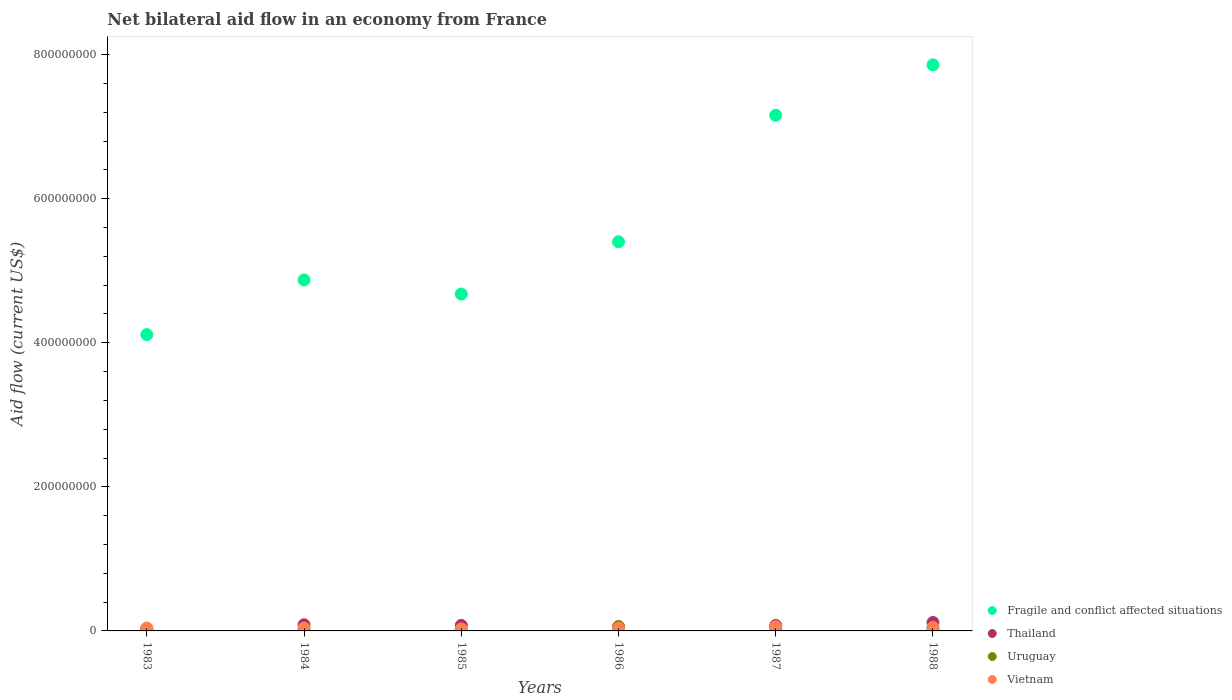Is the number of dotlines equal to the number of legend labels?
Offer a terse response. Yes. What is the net bilateral aid flow in Thailand in 1988?
Offer a terse response. 1.17e+07. Across all years, what is the maximum net bilateral aid flow in Fragile and conflict affected situations?
Offer a very short reply. 7.86e+08. Across all years, what is the minimum net bilateral aid flow in Uruguay?
Provide a succinct answer. 1.18e+06. What is the total net bilateral aid flow in Uruguay in the graph?
Offer a terse response. 1.63e+07. What is the difference between the net bilateral aid flow in Vietnam in 1984 and that in 1985?
Your answer should be very brief. 1.21e+06. What is the difference between the net bilateral aid flow in Uruguay in 1984 and the net bilateral aid flow in Fragile and conflict affected situations in 1983?
Provide a short and direct response. -4.10e+08. What is the average net bilateral aid flow in Vietnam per year?
Provide a succinct answer. 4.24e+06. In the year 1986, what is the difference between the net bilateral aid flow in Uruguay and net bilateral aid flow in Thailand?
Provide a succinct answer. 1.06e+06. In how many years, is the net bilateral aid flow in Fragile and conflict affected situations greater than 400000000 US$?
Your response must be concise. 6. What is the ratio of the net bilateral aid flow in Vietnam in 1983 to that in 1988?
Provide a short and direct response. 0.81. Is the net bilateral aid flow in Fragile and conflict affected situations in 1983 less than that in 1988?
Provide a succinct answer. Yes. What is the difference between the highest and the second highest net bilateral aid flow in Uruguay?
Provide a succinct answer. 2.67e+06. What is the difference between the highest and the lowest net bilateral aid flow in Fragile and conflict affected situations?
Provide a succinct answer. 3.74e+08. Is the sum of the net bilateral aid flow in Vietnam in 1983 and 1987 greater than the maximum net bilateral aid flow in Thailand across all years?
Keep it short and to the point. No. Is the net bilateral aid flow in Fragile and conflict affected situations strictly greater than the net bilateral aid flow in Uruguay over the years?
Offer a terse response. Yes. How many dotlines are there?
Offer a terse response. 4. How many years are there in the graph?
Provide a short and direct response. 6. What is the difference between two consecutive major ticks on the Y-axis?
Keep it short and to the point. 2.00e+08. Does the graph contain any zero values?
Ensure brevity in your answer.  No. Where does the legend appear in the graph?
Your response must be concise. Bottom right. How are the legend labels stacked?
Your answer should be compact. Vertical. What is the title of the graph?
Give a very brief answer. Net bilateral aid flow in an economy from France. Does "Liechtenstein" appear as one of the legend labels in the graph?
Your answer should be compact. No. What is the Aid flow (current US$) of Fragile and conflict affected situations in 1983?
Give a very brief answer. 4.11e+08. What is the Aid flow (current US$) in Thailand in 1983?
Offer a very short reply. 2.84e+06. What is the Aid flow (current US$) of Uruguay in 1983?
Your answer should be compact. 1.50e+06. What is the Aid flow (current US$) in Vietnam in 1983?
Offer a very short reply. 3.98e+06. What is the Aid flow (current US$) in Fragile and conflict affected situations in 1984?
Your answer should be compact. 4.87e+08. What is the Aid flow (current US$) of Thailand in 1984?
Your answer should be very brief. 8.54e+06. What is the Aid flow (current US$) in Uruguay in 1984?
Offer a very short reply. 1.18e+06. What is the Aid flow (current US$) in Vietnam in 1984?
Keep it short and to the point. 3.96e+06. What is the Aid flow (current US$) of Fragile and conflict affected situations in 1985?
Ensure brevity in your answer.  4.68e+08. What is the Aid flow (current US$) of Thailand in 1985?
Give a very brief answer. 7.63e+06. What is the Aid flow (current US$) in Uruguay in 1985?
Give a very brief answer. 1.66e+06. What is the Aid flow (current US$) of Vietnam in 1985?
Make the answer very short. 2.75e+06. What is the Aid flow (current US$) of Fragile and conflict affected situations in 1986?
Give a very brief answer. 5.40e+08. What is the Aid flow (current US$) of Thailand in 1986?
Your answer should be compact. 5.08e+06. What is the Aid flow (current US$) in Uruguay in 1986?
Make the answer very short. 6.14e+06. What is the Aid flow (current US$) in Vietnam in 1986?
Your answer should be compact. 3.90e+06. What is the Aid flow (current US$) of Fragile and conflict affected situations in 1987?
Your response must be concise. 7.16e+08. What is the Aid flow (current US$) in Thailand in 1987?
Your answer should be very brief. 7.65e+06. What is the Aid flow (current US$) of Uruguay in 1987?
Your answer should be very brief. 2.33e+06. What is the Aid flow (current US$) of Vietnam in 1987?
Offer a terse response. 5.94e+06. What is the Aid flow (current US$) in Fragile and conflict affected situations in 1988?
Provide a succinct answer. 7.86e+08. What is the Aid flow (current US$) in Thailand in 1988?
Make the answer very short. 1.17e+07. What is the Aid flow (current US$) of Uruguay in 1988?
Offer a very short reply. 3.47e+06. What is the Aid flow (current US$) in Vietnam in 1988?
Provide a succinct answer. 4.90e+06. Across all years, what is the maximum Aid flow (current US$) of Fragile and conflict affected situations?
Offer a terse response. 7.86e+08. Across all years, what is the maximum Aid flow (current US$) in Thailand?
Keep it short and to the point. 1.17e+07. Across all years, what is the maximum Aid flow (current US$) in Uruguay?
Your response must be concise. 6.14e+06. Across all years, what is the maximum Aid flow (current US$) in Vietnam?
Make the answer very short. 5.94e+06. Across all years, what is the minimum Aid flow (current US$) of Fragile and conflict affected situations?
Your answer should be very brief. 4.11e+08. Across all years, what is the minimum Aid flow (current US$) of Thailand?
Your answer should be compact. 2.84e+06. Across all years, what is the minimum Aid flow (current US$) in Uruguay?
Your answer should be compact. 1.18e+06. Across all years, what is the minimum Aid flow (current US$) in Vietnam?
Your answer should be compact. 2.75e+06. What is the total Aid flow (current US$) in Fragile and conflict affected situations in the graph?
Make the answer very short. 3.41e+09. What is the total Aid flow (current US$) of Thailand in the graph?
Your answer should be very brief. 4.34e+07. What is the total Aid flow (current US$) of Uruguay in the graph?
Your answer should be compact. 1.63e+07. What is the total Aid flow (current US$) in Vietnam in the graph?
Keep it short and to the point. 2.54e+07. What is the difference between the Aid flow (current US$) in Fragile and conflict affected situations in 1983 and that in 1984?
Give a very brief answer. -7.59e+07. What is the difference between the Aid flow (current US$) of Thailand in 1983 and that in 1984?
Ensure brevity in your answer.  -5.70e+06. What is the difference between the Aid flow (current US$) in Uruguay in 1983 and that in 1984?
Offer a very short reply. 3.20e+05. What is the difference between the Aid flow (current US$) in Fragile and conflict affected situations in 1983 and that in 1985?
Make the answer very short. -5.63e+07. What is the difference between the Aid flow (current US$) in Thailand in 1983 and that in 1985?
Offer a terse response. -4.79e+06. What is the difference between the Aid flow (current US$) in Vietnam in 1983 and that in 1985?
Give a very brief answer. 1.23e+06. What is the difference between the Aid flow (current US$) of Fragile and conflict affected situations in 1983 and that in 1986?
Keep it short and to the point. -1.29e+08. What is the difference between the Aid flow (current US$) of Thailand in 1983 and that in 1986?
Ensure brevity in your answer.  -2.24e+06. What is the difference between the Aid flow (current US$) in Uruguay in 1983 and that in 1986?
Provide a short and direct response. -4.64e+06. What is the difference between the Aid flow (current US$) of Vietnam in 1983 and that in 1986?
Give a very brief answer. 8.00e+04. What is the difference between the Aid flow (current US$) of Fragile and conflict affected situations in 1983 and that in 1987?
Your answer should be compact. -3.04e+08. What is the difference between the Aid flow (current US$) in Thailand in 1983 and that in 1987?
Provide a succinct answer. -4.81e+06. What is the difference between the Aid flow (current US$) of Uruguay in 1983 and that in 1987?
Provide a short and direct response. -8.30e+05. What is the difference between the Aid flow (current US$) in Vietnam in 1983 and that in 1987?
Offer a terse response. -1.96e+06. What is the difference between the Aid flow (current US$) in Fragile and conflict affected situations in 1983 and that in 1988?
Provide a short and direct response. -3.74e+08. What is the difference between the Aid flow (current US$) of Thailand in 1983 and that in 1988?
Make the answer very short. -8.84e+06. What is the difference between the Aid flow (current US$) of Uruguay in 1983 and that in 1988?
Make the answer very short. -1.97e+06. What is the difference between the Aid flow (current US$) in Vietnam in 1983 and that in 1988?
Provide a short and direct response. -9.20e+05. What is the difference between the Aid flow (current US$) in Fragile and conflict affected situations in 1984 and that in 1985?
Keep it short and to the point. 1.96e+07. What is the difference between the Aid flow (current US$) in Thailand in 1984 and that in 1985?
Provide a succinct answer. 9.10e+05. What is the difference between the Aid flow (current US$) in Uruguay in 1984 and that in 1985?
Give a very brief answer. -4.80e+05. What is the difference between the Aid flow (current US$) of Vietnam in 1984 and that in 1985?
Provide a short and direct response. 1.21e+06. What is the difference between the Aid flow (current US$) of Fragile and conflict affected situations in 1984 and that in 1986?
Your answer should be compact. -5.29e+07. What is the difference between the Aid flow (current US$) of Thailand in 1984 and that in 1986?
Your answer should be very brief. 3.46e+06. What is the difference between the Aid flow (current US$) of Uruguay in 1984 and that in 1986?
Make the answer very short. -4.96e+06. What is the difference between the Aid flow (current US$) of Vietnam in 1984 and that in 1986?
Keep it short and to the point. 6.00e+04. What is the difference between the Aid flow (current US$) of Fragile and conflict affected situations in 1984 and that in 1987?
Your answer should be compact. -2.29e+08. What is the difference between the Aid flow (current US$) in Thailand in 1984 and that in 1987?
Your response must be concise. 8.90e+05. What is the difference between the Aid flow (current US$) in Uruguay in 1984 and that in 1987?
Provide a succinct answer. -1.15e+06. What is the difference between the Aid flow (current US$) in Vietnam in 1984 and that in 1987?
Provide a succinct answer. -1.98e+06. What is the difference between the Aid flow (current US$) in Fragile and conflict affected situations in 1984 and that in 1988?
Offer a terse response. -2.99e+08. What is the difference between the Aid flow (current US$) in Thailand in 1984 and that in 1988?
Keep it short and to the point. -3.14e+06. What is the difference between the Aid flow (current US$) of Uruguay in 1984 and that in 1988?
Your answer should be very brief. -2.29e+06. What is the difference between the Aid flow (current US$) of Vietnam in 1984 and that in 1988?
Your answer should be compact. -9.40e+05. What is the difference between the Aid flow (current US$) in Fragile and conflict affected situations in 1985 and that in 1986?
Make the answer very short. -7.26e+07. What is the difference between the Aid flow (current US$) of Thailand in 1985 and that in 1986?
Provide a succinct answer. 2.55e+06. What is the difference between the Aid flow (current US$) of Uruguay in 1985 and that in 1986?
Provide a succinct answer. -4.48e+06. What is the difference between the Aid flow (current US$) of Vietnam in 1985 and that in 1986?
Your answer should be compact. -1.15e+06. What is the difference between the Aid flow (current US$) in Fragile and conflict affected situations in 1985 and that in 1987?
Offer a terse response. -2.48e+08. What is the difference between the Aid flow (current US$) in Uruguay in 1985 and that in 1987?
Ensure brevity in your answer.  -6.70e+05. What is the difference between the Aid flow (current US$) in Vietnam in 1985 and that in 1987?
Offer a terse response. -3.19e+06. What is the difference between the Aid flow (current US$) in Fragile and conflict affected situations in 1985 and that in 1988?
Offer a terse response. -3.18e+08. What is the difference between the Aid flow (current US$) of Thailand in 1985 and that in 1988?
Provide a short and direct response. -4.05e+06. What is the difference between the Aid flow (current US$) of Uruguay in 1985 and that in 1988?
Keep it short and to the point. -1.81e+06. What is the difference between the Aid flow (current US$) in Vietnam in 1985 and that in 1988?
Provide a succinct answer. -2.15e+06. What is the difference between the Aid flow (current US$) in Fragile and conflict affected situations in 1986 and that in 1987?
Your answer should be very brief. -1.76e+08. What is the difference between the Aid flow (current US$) of Thailand in 1986 and that in 1987?
Ensure brevity in your answer.  -2.57e+06. What is the difference between the Aid flow (current US$) in Uruguay in 1986 and that in 1987?
Your response must be concise. 3.81e+06. What is the difference between the Aid flow (current US$) in Vietnam in 1986 and that in 1987?
Provide a succinct answer. -2.04e+06. What is the difference between the Aid flow (current US$) in Fragile and conflict affected situations in 1986 and that in 1988?
Your response must be concise. -2.46e+08. What is the difference between the Aid flow (current US$) of Thailand in 1986 and that in 1988?
Your response must be concise. -6.60e+06. What is the difference between the Aid flow (current US$) of Uruguay in 1986 and that in 1988?
Your response must be concise. 2.67e+06. What is the difference between the Aid flow (current US$) of Vietnam in 1986 and that in 1988?
Keep it short and to the point. -1.00e+06. What is the difference between the Aid flow (current US$) in Fragile and conflict affected situations in 1987 and that in 1988?
Your answer should be very brief. -7.00e+07. What is the difference between the Aid flow (current US$) of Thailand in 1987 and that in 1988?
Your response must be concise. -4.03e+06. What is the difference between the Aid flow (current US$) of Uruguay in 1987 and that in 1988?
Make the answer very short. -1.14e+06. What is the difference between the Aid flow (current US$) in Vietnam in 1987 and that in 1988?
Keep it short and to the point. 1.04e+06. What is the difference between the Aid flow (current US$) of Fragile and conflict affected situations in 1983 and the Aid flow (current US$) of Thailand in 1984?
Your answer should be very brief. 4.03e+08. What is the difference between the Aid flow (current US$) in Fragile and conflict affected situations in 1983 and the Aid flow (current US$) in Uruguay in 1984?
Your answer should be very brief. 4.10e+08. What is the difference between the Aid flow (current US$) in Fragile and conflict affected situations in 1983 and the Aid flow (current US$) in Vietnam in 1984?
Your response must be concise. 4.07e+08. What is the difference between the Aid flow (current US$) in Thailand in 1983 and the Aid flow (current US$) in Uruguay in 1984?
Keep it short and to the point. 1.66e+06. What is the difference between the Aid flow (current US$) in Thailand in 1983 and the Aid flow (current US$) in Vietnam in 1984?
Your response must be concise. -1.12e+06. What is the difference between the Aid flow (current US$) in Uruguay in 1983 and the Aid flow (current US$) in Vietnam in 1984?
Your answer should be compact. -2.46e+06. What is the difference between the Aid flow (current US$) of Fragile and conflict affected situations in 1983 and the Aid flow (current US$) of Thailand in 1985?
Ensure brevity in your answer.  4.04e+08. What is the difference between the Aid flow (current US$) in Fragile and conflict affected situations in 1983 and the Aid flow (current US$) in Uruguay in 1985?
Keep it short and to the point. 4.10e+08. What is the difference between the Aid flow (current US$) of Fragile and conflict affected situations in 1983 and the Aid flow (current US$) of Vietnam in 1985?
Offer a very short reply. 4.09e+08. What is the difference between the Aid flow (current US$) of Thailand in 1983 and the Aid flow (current US$) of Uruguay in 1985?
Ensure brevity in your answer.  1.18e+06. What is the difference between the Aid flow (current US$) of Thailand in 1983 and the Aid flow (current US$) of Vietnam in 1985?
Give a very brief answer. 9.00e+04. What is the difference between the Aid flow (current US$) of Uruguay in 1983 and the Aid flow (current US$) of Vietnam in 1985?
Provide a short and direct response. -1.25e+06. What is the difference between the Aid flow (current US$) of Fragile and conflict affected situations in 1983 and the Aid flow (current US$) of Thailand in 1986?
Your answer should be compact. 4.06e+08. What is the difference between the Aid flow (current US$) in Fragile and conflict affected situations in 1983 and the Aid flow (current US$) in Uruguay in 1986?
Offer a terse response. 4.05e+08. What is the difference between the Aid flow (current US$) of Fragile and conflict affected situations in 1983 and the Aid flow (current US$) of Vietnam in 1986?
Offer a terse response. 4.07e+08. What is the difference between the Aid flow (current US$) in Thailand in 1983 and the Aid flow (current US$) in Uruguay in 1986?
Provide a succinct answer. -3.30e+06. What is the difference between the Aid flow (current US$) in Thailand in 1983 and the Aid flow (current US$) in Vietnam in 1986?
Offer a very short reply. -1.06e+06. What is the difference between the Aid flow (current US$) of Uruguay in 1983 and the Aid flow (current US$) of Vietnam in 1986?
Make the answer very short. -2.40e+06. What is the difference between the Aid flow (current US$) of Fragile and conflict affected situations in 1983 and the Aid flow (current US$) of Thailand in 1987?
Keep it short and to the point. 4.04e+08. What is the difference between the Aid flow (current US$) in Fragile and conflict affected situations in 1983 and the Aid flow (current US$) in Uruguay in 1987?
Offer a very short reply. 4.09e+08. What is the difference between the Aid flow (current US$) of Fragile and conflict affected situations in 1983 and the Aid flow (current US$) of Vietnam in 1987?
Offer a very short reply. 4.05e+08. What is the difference between the Aid flow (current US$) in Thailand in 1983 and the Aid flow (current US$) in Uruguay in 1987?
Provide a succinct answer. 5.10e+05. What is the difference between the Aid flow (current US$) in Thailand in 1983 and the Aid flow (current US$) in Vietnam in 1987?
Offer a terse response. -3.10e+06. What is the difference between the Aid flow (current US$) in Uruguay in 1983 and the Aid flow (current US$) in Vietnam in 1987?
Your answer should be compact. -4.44e+06. What is the difference between the Aid flow (current US$) in Fragile and conflict affected situations in 1983 and the Aid flow (current US$) in Thailand in 1988?
Give a very brief answer. 4.00e+08. What is the difference between the Aid flow (current US$) of Fragile and conflict affected situations in 1983 and the Aid flow (current US$) of Uruguay in 1988?
Your answer should be compact. 4.08e+08. What is the difference between the Aid flow (current US$) in Fragile and conflict affected situations in 1983 and the Aid flow (current US$) in Vietnam in 1988?
Give a very brief answer. 4.06e+08. What is the difference between the Aid flow (current US$) of Thailand in 1983 and the Aid flow (current US$) of Uruguay in 1988?
Ensure brevity in your answer.  -6.30e+05. What is the difference between the Aid flow (current US$) in Thailand in 1983 and the Aid flow (current US$) in Vietnam in 1988?
Make the answer very short. -2.06e+06. What is the difference between the Aid flow (current US$) in Uruguay in 1983 and the Aid flow (current US$) in Vietnam in 1988?
Your answer should be compact. -3.40e+06. What is the difference between the Aid flow (current US$) of Fragile and conflict affected situations in 1984 and the Aid flow (current US$) of Thailand in 1985?
Your answer should be very brief. 4.80e+08. What is the difference between the Aid flow (current US$) of Fragile and conflict affected situations in 1984 and the Aid flow (current US$) of Uruguay in 1985?
Keep it short and to the point. 4.86e+08. What is the difference between the Aid flow (current US$) in Fragile and conflict affected situations in 1984 and the Aid flow (current US$) in Vietnam in 1985?
Give a very brief answer. 4.84e+08. What is the difference between the Aid flow (current US$) in Thailand in 1984 and the Aid flow (current US$) in Uruguay in 1985?
Your response must be concise. 6.88e+06. What is the difference between the Aid flow (current US$) in Thailand in 1984 and the Aid flow (current US$) in Vietnam in 1985?
Ensure brevity in your answer.  5.79e+06. What is the difference between the Aid flow (current US$) of Uruguay in 1984 and the Aid flow (current US$) of Vietnam in 1985?
Give a very brief answer. -1.57e+06. What is the difference between the Aid flow (current US$) in Fragile and conflict affected situations in 1984 and the Aid flow (current US$) in Thailand in 1986?
Your answer should be compact. 4.82e+08. What is the difference between the Aid flow (current US$) of Fragile and conflict affected situations in 1984 and the Aid flow (current US$) of Uruguay in 1986?
Your response must be concise. 4.81e+08. What is the difference between the Aid flow (current US$) of Fragile and conflict affected situations in 1984 and the Aid flow (current US$) of Vietnam in 1986?
Your answer should be very brief. 4.83e+08. What is the difference between the Aid flow (current US$) in Thailand in 1984 and the Aid flow (current US$) in Uruguay in 1986?
Provide a short and direct response. 2.40e+06. What is the difference between the Aid flow (current US$) of Thailand in 1984 and the Aid flow (current US$) of Vietnam in 1986?
Your response must be concise. 4.64e+06. What is the difference between the Aid flow (current US$) in Uruguay in 1984 and the Aid flow (current US$) in Vietnam in 1986?
Make the answer very short. -2.72e+06. What is the difference between the Aid flow (current US$) of Fragile and conflict affected situations in 1984 and the Aid flow (current US$) of Thailand in 1987?
Your response must be concise. 4.80e+08. What is the difference between the Aid flow (current US$) of Fragile and conflict affected situations in 1984 and the Aid flow (current US$) of Uruguay in 1987?
Provide a short and direct response. 4.85e+08. What is the difference between the Aid flow (current US$) of Fragile and conflict affected situations in 1984 and the Aid flow (current US$) of Vietnam in 1987?
Your answer should be very brief. 4.81e+08. What is the difference between the Aid flow (current US$) of Thailand in 1984 and the Aid flow (current US$) of Uruguay in 1987?
Provide a succinct answer. 6.21e+06. What is the difference between the Aid flow (current US$) in Thailand in 1984 and the Aid flow (current US$) in Vietnam in 1987?
Provide a short and direct response. 2.60e+06. What is the difference between the Aid flow (current US$) of Uruguay in 1984 and the Aid flow (current US$) of Vietnam in 1987?
Offer a very short reply. -4.76e+06. What is the difference between the Aid flow (current US$) of Fragile and conflict affected situations in 1984 and the Aid flow (current US$) of Thailand in 1988?
Give a very brief answer. 4.76e+08. What is the difference between the Aid flow (current US$) in Fragile and conflict affected situations in 1984 and the Aid flow (current US$) in Uruguay in 1988?
Provide a short and direct response. 4.84e+08. What is the difference between the Aid flow (current US$) in Fragile and conflict affected situations in 1984 and the Aid flow (current US$) in Vietnam in 1988?
Offer a very short reply. 4.82e+08. What is the difference between the Aid flow (current US$) of Thailand in 1984 and the Aid flow (current US$) of Uruguay in 1988?
Your answer should be very brief. 5.07e+06. What is the difference between the Aid flow (current US$) of Thailand in 1984 and the Aid flow (current US$) of Vietnam in 1988?
Offer a very short reply. 3.64e+06. What is the difference between the Aid flow (current US$) in Uruguay in 1984 and the Aid flow (current US$) in Vietnam in 1988?
Provide a short and direct response. -3.72e+06. What is the difference between the Aid flow (current US$) of Fragile and conflict affected situations in 1985 and the Aid flow (current US$) of Thailand in 1986?
Make the answer very short. 4.63e+08. What is the difference between the Aid flow (current US$) in Fragile and conflict affected situations in 1985 and the Aid flow (current US$) in Uruguay in 1986?
Offer a terse response. 4.61e+08. What is the difference between the Aid flow (current US$) of Fragile and conflict affected situations in 1985 and the Aid flow (current US$) of Vietnam in 1986?
Make the answer very short. 4.64e+08. What is the difference between the Aid flow (current US$) in Thailand in 1985 and the Aid flow (current US$) in Uruguay in 1986?
Make the answer very short. 1.49e+06. What is the difference between the Aid flow (current US$) of Thailand in 1985 and the Aid flow (current US$) of Vietnam in 1986?
Provide a short and direct response. 3.73e+06. What is the difference between the Aid flow (current US$) in Uruguay in 1985 and the Aid flow (current US$) in Vietnam in 1986?
Give a very brief answer. -2.24e+06. What is the difference between the Aid flow (current US$) in Fragile and conflict affected situations in 1985 and the Aid flow (current US$) in Thailand in 1987?
Make the answer very short. 4.60e+08. What is the difference between the Aid flow (current US$) of Fragile and conflict affected situations in 1985 and the Aid flow (current US$) of Uruguay in 1987?
Provide a succinct answer. 4.65e+08. What is the difference between the Aid flow (current US$) of Fragile and conflict affected situations in 1985 and the Aid flow (current US$) of Vietnam in 1987?
Your answer should be very brief. 4.62e+08. What is the difference between the Aid flow (current US$) in Thailand in 1985 and the Aid flow (current US$) in Uruguay in 1987?
Give a very brief answer. 5.30e+06. What is the difference between the Aid flow (current US$) of Thailand in 1985 and the Aid flow (current US$) of Vietnam in 1987?
Make the answer very short. 1.69e+06. What is the difference between the Aid flow (current US$) in Uruguay in 1985 and the Aid flow (current US$) in Vietnam in 1987?
Keep it short and to the point. -4.28e+06. What is the difference between the Aid flow (current US$) of Fragile and conflict affected situations in 1985 and the Aid flow (current US$) of Thailand in 1988?
Give a very brief answer. 4.56e+08. What is the difference between the Aid flow (current US$) in Fragile and conflict affected situations in 1985 and the Aid flow (current US$) in Uruguay in 1988?
Provide a succinct answer. 4.64e+08. What is the difference between the Aid flow (current US$) of Fragile and conflict affected situations in 1985 and the Aid flow (current US$) of Vietnam in 1988?
Your answer should be very brief. 4.63e+08. What is the difference between the Aid flow (current US$) in Thailand in 1985 and the Aid flow (current US$) in Uruguay in 1988?
Your response must be concise. 4.16e+06. What is the difference between the Aid flow (current US$) in Thailand in 1985 and the Aid flow (current US$) in Vietnam in 1988?
Ensure brevity in your answer.  2.73e+06. What is the difference between the Aid flow (current US$) of Uruguay in 1985 and the Aid flow (current US$) of Vietnam in 1988?
Offer a terse response. -3.24e+06. What is the difference between the Aid flow (current US$) of Fragile and conflict affected situations in 1986 and the Aid flow (current US$) of Thailand in 1987?
Ensure brevity in your answer.  5.33e+08. What is the difference between the Aid flow (current US$) in Fragile and conflict affected situations in 1986 and the Aid flow (current US$) in Uruguay in 1987?
Your answer should be very brief. 5.38e+08. What is the difference between the Aid flow (current US$) of Fragile and conflict affected situations in 1986 and the Aid flow (current US$) of Vietnam in 1987?
Make the answer very short. 5.34e+08. What is the difference between the Aid flow (current US$) in Thailand in 1986 and the Aid flow (current US$) in Uruguay in 1987?
Provide a succinct answer. 2.75e+06. What is the difference between the Aid flow (current US$) in Thailand in 1986 and the Aid flow (current US$) in Vietnam in 1987?
Provide a succinct answer. -8.60e+05. What is the difference between the Aid flow (current US$) in Uruguay in 1986 and the Aid flow (current US$) in Vietnam in 1987?
Offer a very short reply. 2.00e+05. What is the difference between the Aid flow (current US$) in Fragile and conflict affected situations in 1986 and the Aid flow (current US$) in Thailand in 1988?
Offer a terse response. 5.28e+08. What is the difference between the Aid flow (current US$) of Fragile and conflict affected situations in 1986 and the Aid flow (current US$) of Uruguay in 1988?
Give a very brief answer. 5.37e+08. What is the difference between the Aid flow (current US$) of Fragile and conflict affected situations in 1986 and the Aid flow (current US$) of Vietnam in 1988?
Provide a succinct answer. 5.35e+08. What is the difference between the Aid flow (current US$) in Thailand in 1986 and the Aid flow (current US$) in Uruguay in 1988?
Offer a terse response. 1.61e+06. What is the difference between the Aid flow (current US$) in Thailand in 1986 and the Aid flow (current US$) in Vietnam in 1988?
Make the answer very short. 1.80e+05. What is the difference between the Aid flow (current US$) of Uruguay in 1986 and the Aid flow (current US$) of Vietnam in 1988?
Your answer should be very brief. 1.24e+06. What is the difference between the Aid flow (current US$) in Fragile and conflict affected situations in 1987 and the Aid flow (current US$) in Thailand in 1988?
Offer a terse response. 7.04e+08. What is the difference between the Aid flow (current US$) of Fragile and conflict affected situations in 1987 and the Aid flow (current US$) of Uruguay in 1988?
Ensure brevity in your answer.  7.12e+08. What is the difference between the Aid flow (current US$) in Fragile and conflict affected situations in 1987 and the Aid flow (current US$) in Vietnam in 1988?
Keep it short and to the point. 7.11e+08. What is the difference between the Aid flow (current US$) of Thailand in 1987 and the Aid flow (current US$) of Uruguay in 1988?
Your response must be concise. 4.18e+06. What is the difference between the Aid flow (current US$) in Thailand in 1987 and the Aid flow (current US$) in Vietnam in 1988?
Make the answer very short. 2.75e+06. What is the difference between the Aid flow (current US$) in Uruguay in 1987 and the Aid flow (current US$) in Vietnam in 1988?
Provide a succinct answer. -2.57e+06. What is the average Aid flow (current US$) of Fragile and conflict affected situations per year?
Make the answer very short. 5.68e+08. What is the average Aid flow (current US$) in Thailand per year?
Offer a very short reply. 7.24e+06. What is the average Aid flow (current US$) of Uruguay per year?
Offer a very short reply. 2.71e+06. What is the average Aid flow (current US$) of Vietnam per year?
Give a very brief answer. 4.24e+06. In the year 1983, what is the difference between the Aid flow (current US$) in Fragile and conflict affected situations and Aid flow (current US$) in Thailand?
Ensure brevity in your answer.  4.08e+08. In the year 1983, what is the difference between the Aid flow (current US$) of Fragile and conflict affected situations and Aid flow (current US$) of Uruguay?
Provide a short and direct response. 4.10e+08. In the year 1983, what is the difference between the Aid flow (current US$) in Fragile and conflict affected situations and Aid flow (current US$) in Vietnam?
Make the answer very short. 4.07e+08. In the year 1983, what is the difference between the Aid flow (current US$) in Thailand and Aid flow (current US$) in Uruguay?
Make the answer very short. 1.34e+06. In the year 1983, what is the difference between the Aid flow (current US$) of Thailand and Aid flow (current US$) of Vietnam?
Offer a terse response. -1.14e+06. In the year 1983, what is the difference between the Aid flow (current US$) of Uruguay and Aid flow (current US$) of Vietnam?
Make the answer very short. -2.48e+06. In the year 1984, what is the difference between the Aid flow (current US$) in Fragile and conflict affected situations and Aid flow (current US$) in Thailand?
Make the answer very short. 4.79e+08. In the year 1984, what is the difference between the Aid flow (current US$) of Fragile and conflict affected situations and Aid flow (current US$) of Uruguay?
Make the answer very short. 4.86e+08. In the year 1984, what is the difference between the Aid flow (current US$) in Fragile and conflict affected situations and Aid flow (current US$) in Vietnam?
Offer a very short reply. 4.83e+08. In the year 1984, what is the difference between the Aid flow (current US$) in Thailand and Aid flow (current US$) in Uruguay?
Ensure brevity in your answer.  7.36e+06. In the year 1984, what is the difference between the Aid flow (current US$) in Thailand and Aid flow (current US$) in Vietnam?
Give a very brief answer. 4.58e+06. In the year 1984, what is the difference between the Aid flow (current US$) in Uruguay and Aid flow (current US$) in Vietnam?
Provide a succinct answer. -2.78e+06. In the year 1985, what is the difference between the Aid flow (current US$) of Fragile and conflict affected situations and Aid flow (current US$) of Thailand?
Your answer should be compact. 4.60e+08. In the year 1985, what is the difference between the Aid flow (current US$) of Fragile and conflict affected situations and Aid flow (current US$) of Uruguay?
Make the answer very short. 4.66e+08. In the year 1985, what is the difference between the Aid flow (current US$) in Fragile and conflict affected situations and Aid flow (current US$) in Vietnam?
Your answer should be compact. 4.65e+08. In the year 1985, what is the difference between the Aid flow (current US$) of Thailand and Aid flow (current US$) of Uruguay?
Make the answer very short. 5.97e+06. In the year 1985, what is the difference between the Aid flow (current US$) of Thailand and Aid flow (current US$) of Vietnam?
Make the answer very short. 4.88e+06. In the year 1985, what is the difference between the Aid flow (current US$) in Uruguay and Aid flow (current US$) in Vietnam?
Give a very brief answer. -1.09e+06. In the year 1986, what is the difference between the Aid flow (current US$) in Fragile and conflict affected situations and Aid flow (current US$) in Thailand?
Provide a succinct answer. 5.35e+08. In the year 1986, what is the difference between the Aid flow (current US$) in Fragile and conflict affected situations and Aid flow (current US$) in Uruguay?
Your answer should be compact. 5.34e+08. In the year 1986, what is the difference between the Aid flow (current US$) of Fragile and conflict affected situations and Aid flow (current US$) of Vietnam?
Keep it short and to the point. 5.36e+08. In the year 1986, what is the difference between the Aid flow (current US$) of Thailand and Aid flow (current US$) of Uruguay?
Keep it short and to the point. -1.06e+06. In the year 1986, what is the difference between the Aid flow (current US$) of Thailand and Aid flow (current US$) of Vietnam?
Give a very brief answer. 1.18e+06. In the year 1986, what is the difference between the Aid flow (current US$) in Uruguay and Aid flow (current US$) in Vietnam?
Give a very brief answer. 2.24e+06. In the year 1987, what is the difference between the Aid flow (current US$) of Fragile and conflict affected situations and Aid flow (current US$) of Thailand?
Your response must be concise. 7.08e+08. In the year 1987, what is the difference between the Aid flow (current US$) of Fragile and conflict affected situations and Aid flow (current US$) of Uruguay?
Provide a short and direct response. 7.13e+08. In the year 1987, what is the difference between the Aid flow (current US$) of Fragile and conflict affected situations and Aid flow (current US$) of Vietnam?
Offer a very short reply. 7.10e+08. In the year 1987, what is the difference between the Aid flow (current US$) in Thailand and Aid flow (current US$) in Uruguay?
Your answer should be very brief. 5.32e+06. In the year 1987, what is the difference between the Aid flow (current US$) in Thailand and Aid flow (current US$) in Vietnam?
Your answer should be very brief. 1.71e+06. In the year 1987, what is the difference between the Aid flow (current US$) of Uruguay and Aid flow (current US$) of Vietnam?
Your answer should be compact. -3.61e+06. In the year 1988, what is the difference between the Aid flow (current US$) of Fragile and conflict affected situations and Aid flow (current US$) of Thailand?
Offer a very short reply. 7.74e+08. In the year 1988, what is the difference between the Aid flow (current US$) of Fragile and conflict affected situations and Aid flow (current US$) of Uruguay?
Give a very brief answer. 7.82e+08. In the year 1988, what is the difference between the Aid flow (current US$) of Fragile and conflict affected situations and Aid flow (current US$) of Vietnam?
Give a very brief answer. 7.81e+08. In the year 1988, what is the difference between the Aid flow (current US$) of Thailand and Aid flow (current US$) of Uruguay?
Your response must be concise. 8.21e+06. In the year 1988, what is the difference between the Aid flow (current US$) in Thailand and Aid flow (current US$) in Vietnam?
Give a very brief answer. 6.78e+06. In the year 1988, what is the difference between the Aid flow (current US$) in Uruguay and Aid flow (current US$) in Vietnam?
Provide a short and direct response. -1.43e+06. What is the ratio of the Aid flow (current US$) in Fragile and conflict affected situations in 1983 to that in 1984?
Your response must be concise. 0.84. What is the ratio of the Aid flow (current US$) of Thailand in 1983 to that in 1984?
Give a very brief answer. 0.33. What is the ratio of the Aid flow (current US$) in Uruguay in 1983 to that in 1984?
Your response must be concise. 1.27. What is the ratio of the Aid flow (current US$) of Vietnam in 1983 to that in 1984?
Your answer should be compact. 1.01. What is the ratio of the Aid flow (current US$) in Fragile and conflict affected situations in 1983 to that in 1985?
Ensure brevity in your answer.  0.88. What is the ratio of the Aid flow (current US$) in Thailand in 1983 to that in 1985?
Keep it short and to the point. 0.37. What is the ratio of the Aid flow (current US$) of Uruguay in 1983 to that in 1985?
Offer a very short reply. 0.9. What is the ratio of the Aid flow (current US$) of Vietnam in 1983 to that in 1985?
Provide a succinct answer. 1.45. What is the ratio of the Aid flow (current US$) of Fragile and conflict affected situations in 1983 to that in 1986?
Ensure brevity in your answer.  0.76. What is the ratio of the Aid flow (current US$) in Thailand in 1983 to that in 1986?
Give a very brief answer. 0.56. What is the ratio of the Aid flow (current US$) of Uruguay in 1983 to that in 1986?
Your answer should be compact. 0.24. What is the ratio of the Aid flow (current US$) of Vietnam in 1983 to that in 1986?
Give a very brief answer. 1.02. What is the ratio of the Aid flow (current US$) of Fragile and conflict affected situations in 1983 to that in 1987?
Offer a very short reply. 0.57. What is the ratio of the Aid flow (current US$) of Thailand in 1983 to that in 1987?
Your answer should be very brief. 0.37. What is the ratio of the Aid flow (current US$) of Uruguay in 1983 to that in 1987?
Your answer should be very brief. 0.64. What is the ratio of the Aid flow (current US$) in Vietnam in 1983 to that in 1987?
Make the answer very short. 0.67. What is the ratio of the Aid flow (current US$) in Fragile and conflict affected situations in 1983 to that in 1988?
Make the answer very short. 0.52. What is the ratio of the Aid flow (current US$) in Thailand in 1983 to that in 1988?
Keep it short and to the point. 0.24. What is the ratio of the Aid flow (current US$) of Uruguay in 1983 to that in 1988?
Make the answer very short. 0.43. What is the ratio of the Aid flow (current US$) in Vietnam in 1983 to that in 1988?
Provide a short and direct response. 0.81. What is the ratio of the Aid flow (current US$) in Fragile and conflict affected situations in 1984 to that in 1985?
Offer a terse response. 1.04. What is the ratio of the Aid flow (current US$) of Thailand in 1984 to that in 1985?
Provide a succinct answer. 1.12. What is the ratio of the Aid flow (current US$) of Uruguay in 1984 to that in 1985?
Your response must be concise. 0.71. What is the ratio of the Aid flow (current US$) in Vietnam in 1984 to that in 1985?
Provide a succinct answer. 1.44. What is the ratio of the Aid flow (current US$) in Fragile and conflict affected situations in 1984 to that in 1986?
Your response must be concise. 0.9. What is the ratio of the Aid flow (current US$) of Thailand in 1984 to that in 1986?
Keep it short and to the point. 1.68. What is the ratio of the Aid flow (current US$) in Uruguay in 1984 to that in 1986?
Offer a very short reply. 0.19. What is the ratio of the Aid flow (current US$) in Vietnam in 1984 to that in 1986?
Keep it short and to the point. 1.02. What is the ratio of the Aid flow (current US$) in Fragile and conflict affected situations in 1984 to that in 1987?
Provide a short and direct response. 0.68. What is the ratio of the Aid flow (current US$) in Thailand in 1984 to that in 1987?
Offer a terse response. 1.12. What is the ratio of the Aid flow (current US$) in Uruguay in 1984 to that in 1987?
Make the answer very short. 0.51. What is the ratio of the Aid flow (current US$) in Vietnam in 1984 to that in 1987?
Make the answer very short. 0.67. What is the ratio of the Aid flow (current US$) in Fragile and conflict affected situations in 1984 to that in 1988?
Provide a succinct answer. 0.62. What is the ratio of the Aid flow (current US$) of Thailand in 1984 to that in 1988?
Make the answer very short. 0.73. What is the ratio of the Aid flow (current US$) in Uruguay in 1984 to that in 1988?
Your answer should be very brief. 0.34. What is the ratio of the Aid flow (current US$) of Vietnam in 1984 to that in 1988?
Offer a terse response. 0.81. What is the ratio of the Aid flow (current US$) of Fragile and conflict affected situations in 1985 to that in 1986?
Your response must be concise. 0.87. What is the ratio of the Aid flow (current US$) in Thailand in 1985 to that in 1986?
Ensure brevity in your answer.  1.5. What is the ratio of the Aid flow (current US$) of Uruguay in 1985 to that in 1986?
Offer a very short reply. 0.27. What is the ratio of the Aid flow (current US$) in Vietnam in 1985 to that in 1986?
Your response must be concise. 0.71. What is the ratio of the Aid flow (current US$) of Fragile and conflict affected situations in 1985 to that in 1987?
Keep it short and to the point. 0.65. What is the ratio of the Aid flow (current US$) in Thailand in 1985 to that in 1987?
Your response must be concise. 1. What is the ratio of the Aid flow (current US$) of Uruguay in 1985 to that in 1987?
Provide a short and direct response. 0.71. What is the ratio of the Aid flow (current US$) of Vietnam in 1985 to that in 1987?
Your response must be concise. 0.46. What is the ratio of the Aid flow (current US$) of Fragile and conflict affected situations in 1985 to that in 1988?
Give a very brief answer. 0.6. What is the ratio of the Aid flow (current US$) of Thailand in 1985 to that in 1988?
Offer a very short reply. 0.65. What is the ratio of the Aid flow (current US$) of Uruguay in 1985 to that in 1988?
Make the answer very short. 0.48. What is the ratio of the Aid flow (current US$) of Vietnam in 1985 to that in 1988?
Provide a succinct answer. 0.56. What is the ratio of the Aid flow (current US$) of Fragile and conflict affected situations in 1986 to that in 1987?
Your answer should be very brief. 0.75. What is the ratio of the Aid flow (current US$) of Thailand in 1986 to that in 1987?
Ensure brevity in your answer.  0.66. What is the ratio of the Aid flow (current US$) of Uruguay in 1986 to that in 1987?
Make the answer very short. 2.64. What is the ratio of the Aid flow (current US$) in Vietnam in 1986 to that in 1987?
Your answer should be compact. 0.66. What is the ratio of the Aid flow (current US$) of Fragile and conflict affected situations in 1986 to that in 1988?
Provide a succinct answer. 0.69. What is the ratio of the Aid flow (current US$) of Thailand in 1986 to that in 1988?
Ensure brevity in your answer.  0.43. What is the ratio of the Aid flow (current US$) in Uruguay in 1986 to that in 1988?
Make the answer very short. 1.77. What is the ratio of the Aid flow (current US$) of Vietnam in 1986 to that in 1988?
Provide a short and direct response. 0.8. What is the ratio of the Aid flow (current US$) in Fragile and conflict affected situations in 1987 to that in 1988?
Keep it short and to the point. 0.91. What is the ratio of the Aid flow (current US$) of Thailand in 1987 to that in 1988?
Keep it short and to the point. 0.66. What is the ratio of the Aid flow (current US$) in Uruguay in 1987 to that in 1988?
Give a very brief answer. 0.67. What is the ratio of the Aid flow (current US$) of Vietnam in 1987 to that in 1988?
Give a very brief answer. 1.21. What is the difference between the highest and the second highest Aid flow (current US$) in Fragile and conflict affected situations?
Provide a short and direct response. 7.00e+07. What is the difference between the highest and the second highest Aid flow (current US$) in Thailand?
Your answer should be very brief. 3.14e+06. What is the difference between the highest and the second highest Aid flow (current US$) of Uruguay?
Your answer should be very brief. 2.67e+06. What is the difference between the highest and the second highest Aid flow (current US$) of Vietnam?
Your answer should be compact. 1.04e+06. What is the difference between the highest and the lowest Aid flow (current US$) in Fragile and conflict affected situations?
Give a very brief answer. 3.74e+08. What is the difference between the highest and the lowest Aid flow (current US$) in Thailand?
Ensure brevity in your answer.  8.84e+06. What is the difference between the highest and the lowest Aid flow (current US$) in Uruguay?
Provide a succinct answer. 4.96e+06. What is the difference between the highest and the lowest Aid flow (current US$) of Vietnam?
Make the answer very short. 3.19e+06. 